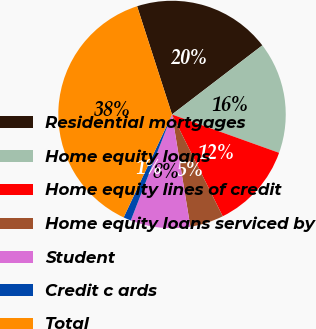Convert chart to OTSL. <chart><loc_0><loc_0><loc_500><loc_500><pie_chart><fcel>Residential mortgages<fcel>Home equity loans<fcel>Home equity lines of credit<fcel>Home equity loans serviced by<fcel>Student<fcel>Credit c ards<fcel>Total<nl><fcel>19.57%<fcel>15.87%<fcel>12.17%<fcel>4.78%<fcel>8.48%<fcel>1.09%<fcel>38.04%<nl></chart> 